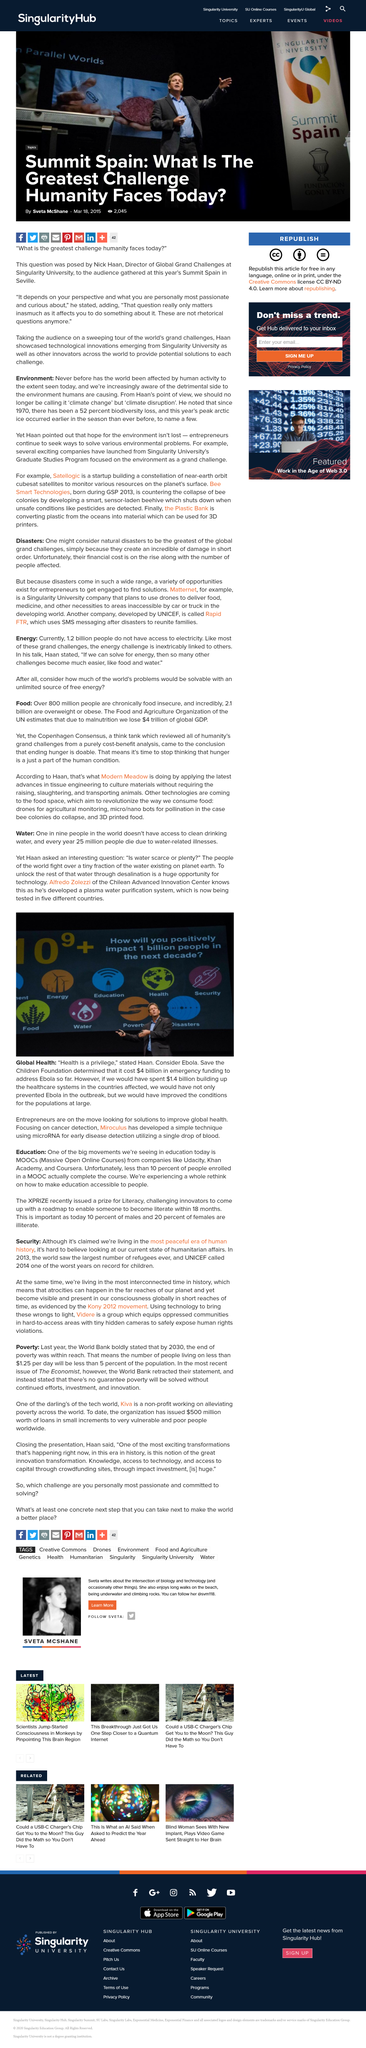List a handful of essential elements in this visual. As of the time this article was written, the cost of emergency funding to address the Ebola outbreak was approximately $4 billion. Miroculus is dedicated to the early detection of cancer. It is estimated that preventing the Ebola outbreak would have cost approximately $1.4 billion. 